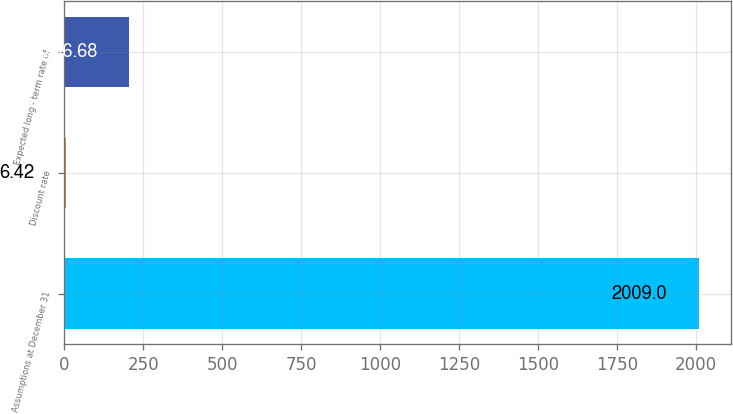<chart> <loc_0><loc_0><loc_500><loc_500><bar_chart><fcel>Assumptions at December 31<fcel>Discount rate<fcel>Expected long - term rate of<nl><fcel>2009<fcel>6.42<fcel>206.68<nl></chart> 